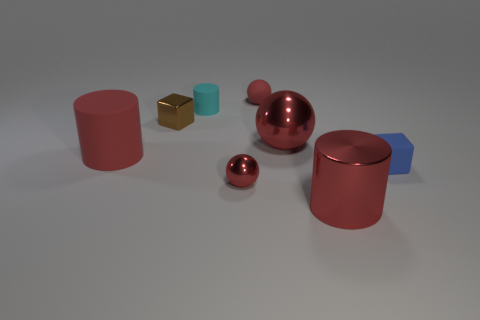Subtract all green blocks. How many red cylinders are left? 2 Subtract all tiny matte cylinders. How many cylinders are left? 2 Subtract 1 cylinders. How many cylinders are left? 2 Add 1 blue blocks. How many objects exist? 9 Subtract all cylinders. How many objects are left? 5 Subtract all big yellow balls. Subtract all shiny objects. How many objects are left? 4 Add 2 rubber cubes. How many rubber cubes are left? 3 Add 8 blue cubes. How many blue cubes exist? 9 Subtract 0 yellow cubes. How many objects are left? 8 